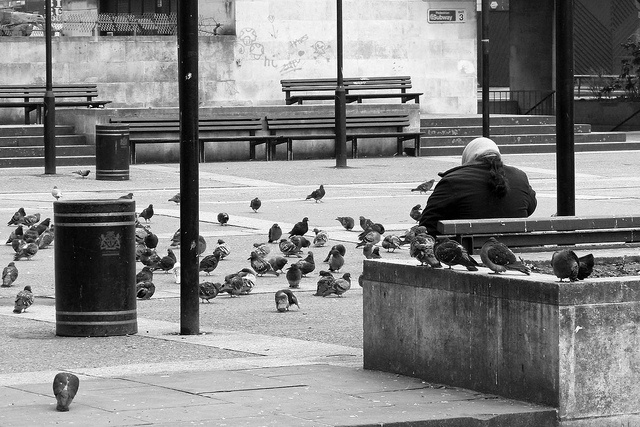Describe the objects in this image and their specific colors. I can see bird in gray, lightgray, black, and darkgray tones, bench in gray, black, and lightgray tones, people in gray, black, lightgray, and darkgray tones, bench in gray, black, darkgray, and lightgray tones, and bench in gray, black, darkgray, and lightgray tones in this image. 